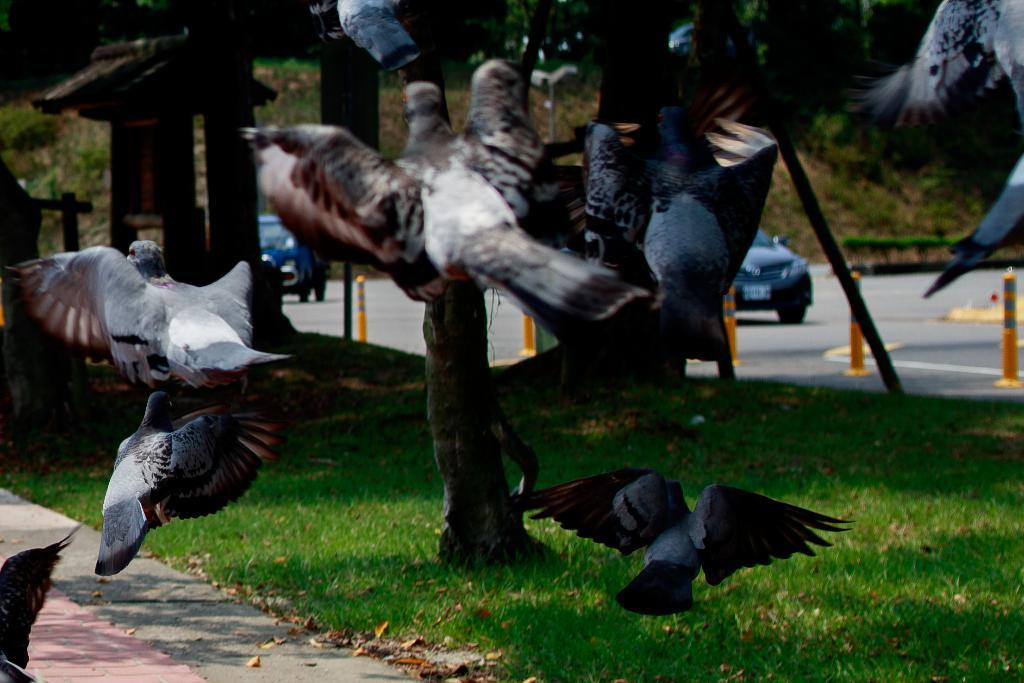What is happening in the sky in the image? There are birds flying in the air in the image. What can be seen in the background of the image? There are vehicles on the road, grass, trees, and other objects present in the background of the image. How many kittens are playing with the rabbits in the image? There are no kittens or rabbits present in the image. Can you describe the push of the vehicles on the road in the image? The vehicles on the road are stationary, so there is no push to describe. 